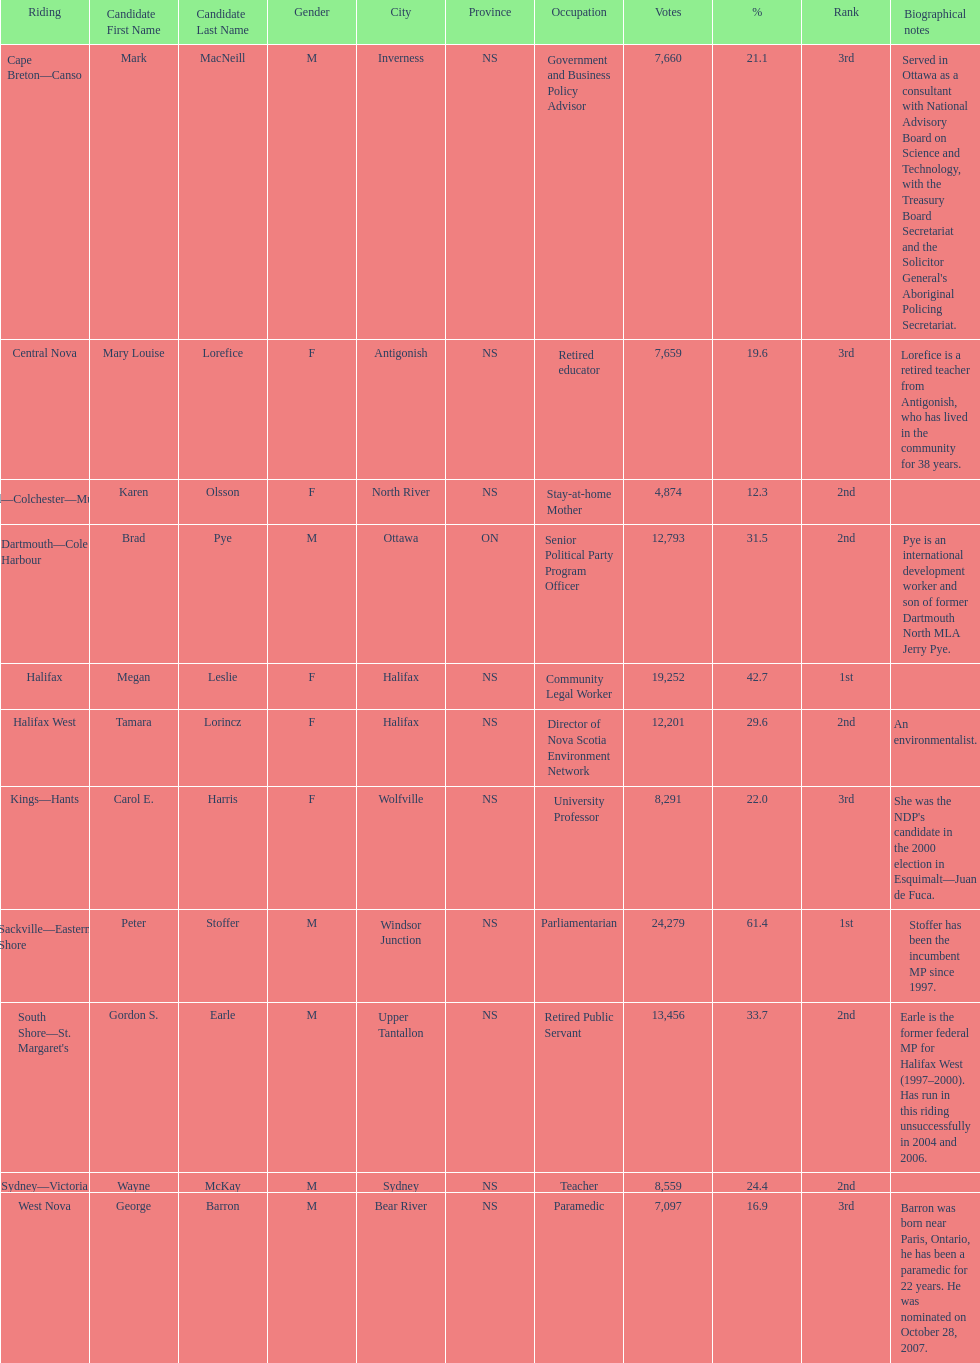Who received the least amount of votes? Karen Olsson. 